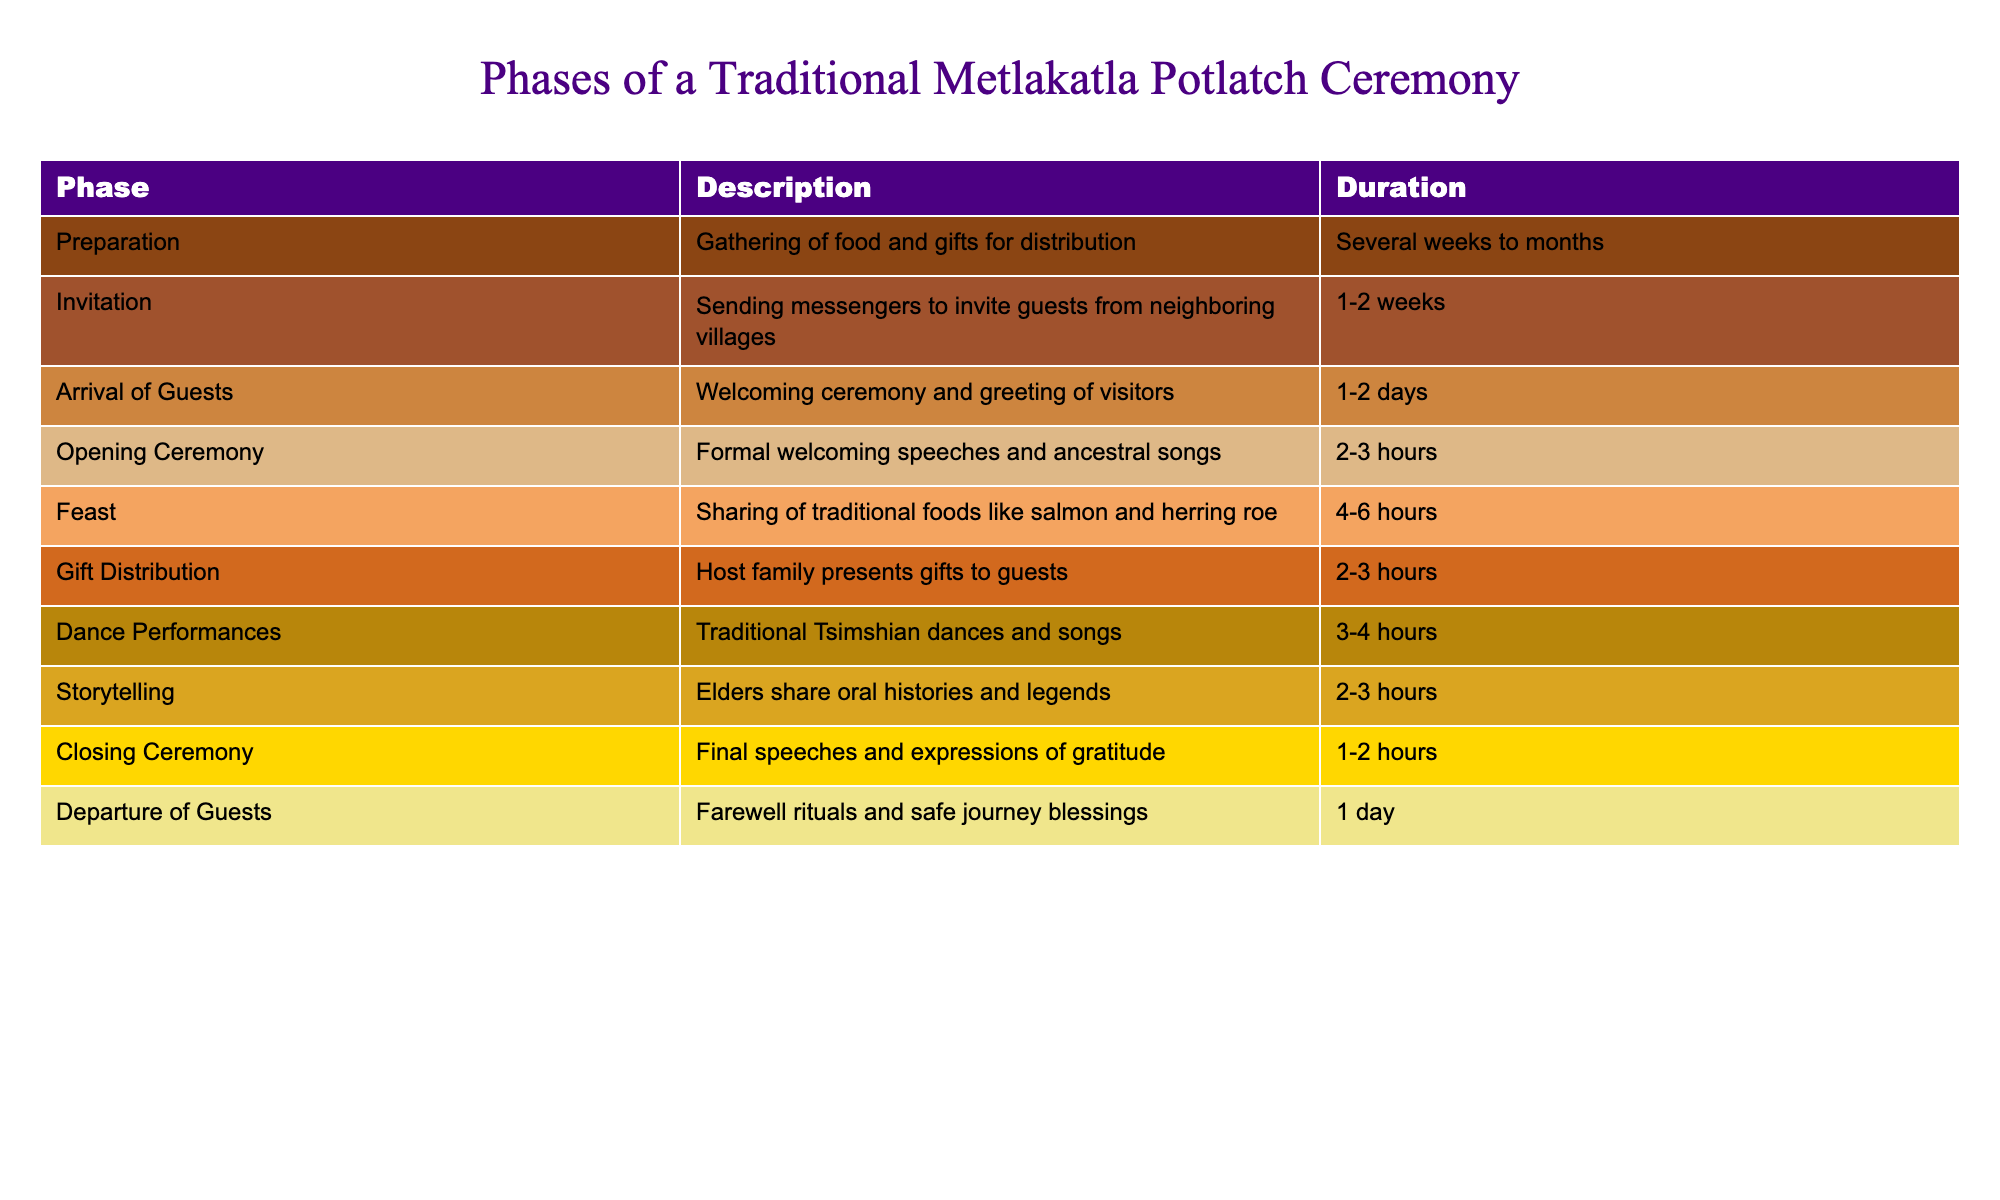What is the duration of the Feast phase? The Feast phase of the ceremony has a duration listed in the table as 4-6 hours.
Answer: 4-6 hours How many days does the Arrival of Guests phase last? According to the table, the Arrival of Guests phase lasts for 1-2 days.
Answer: 1-2 days Is the Gift Distribution phase longer than the Opening Ceremony? The Gift Distribution phase lasts 2-3 hours, while the Opening Ceremony lasts 2-3 hours as well, making them of equal duration. Therefore, the statement is false.
Answer: No What phases have a duration of less than a day? The phases that last less than a day include Opening Ceremony (2-3 hours), Feast (4-6 hours), Gift Distribution (2-3 hours), Dance Performances (3-4 hours), Storytelling (2-3 hours), and Closing Ceremony (1-2 hours).
Answer: 6 phases What is the total duration of the preparation and invitation phases combined? The Preparation phase takes several weeks to months, which is not a specific numerical duration. The Invitation phase takes 1-2 weeks, which is equivalent to approximately 1.5 weeks for an average. Therefore, a strict numerical total cannot be formed due to the ambiguity of the Preparation phase. The conclusion is that we cannot determine an exact total duration with the given information.
Answer: Cannot determine Which phase has the longest duration and what is it? By analyzing the durations provided in the table, the Preparation phase is noted as taking several weeks to months, indicating it is the longest phase compared to others listed with more specific time frames.
Answer: Preparation phase Do any phases last exactly 1 day? Only the Departure of Guests phase is stated to last for 1 day, according to the table. Thus, the answer is yes.
Answer: Yes What are the two phases that take the least time? The phases with the least duration listed are the Opening Ceremony and the Closing Ceremony, each of which takes 1-2 hours.
Answer: Opening Ceremony and Closing Ceremony 